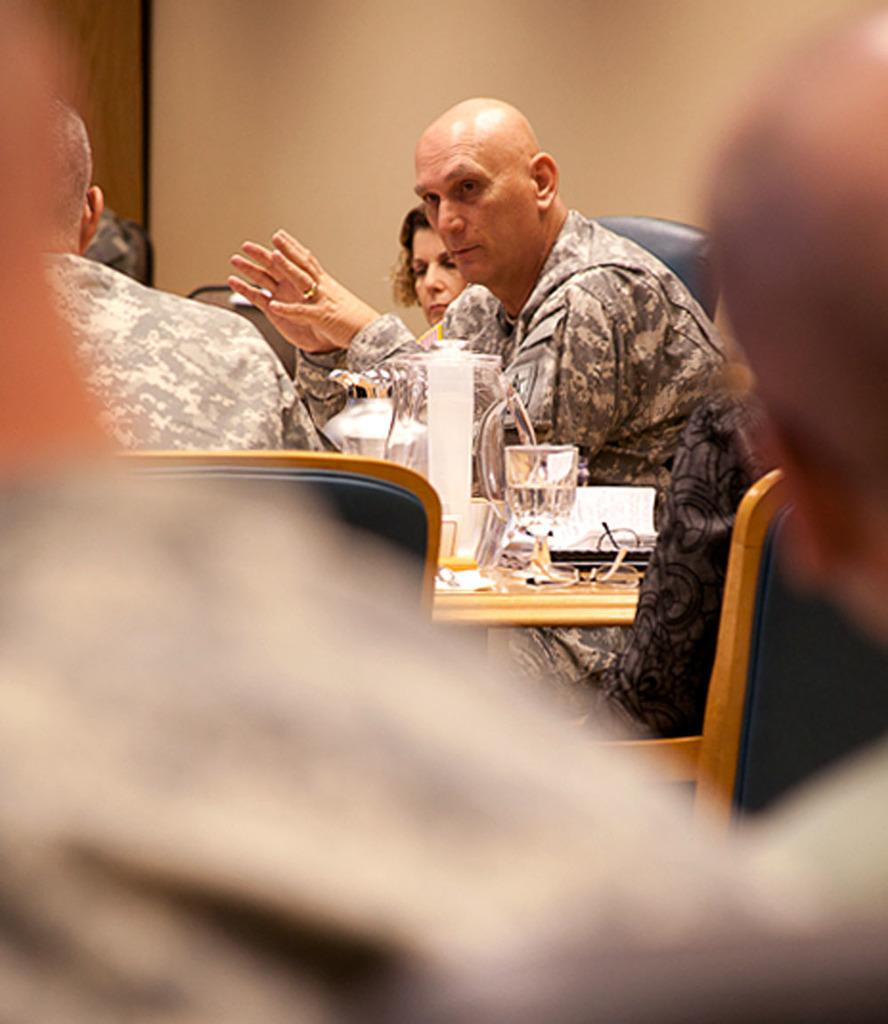How many people are sitting in the image? There are three people sitting on chairs in the image. What can be seen on the table in the image? There is a glass, a jar, and an object on the table in the image. What is the background of the image? There is a wall in the background of the image. What type of note is being passed between the people in the image? There is no note being passed between the people in the image. 